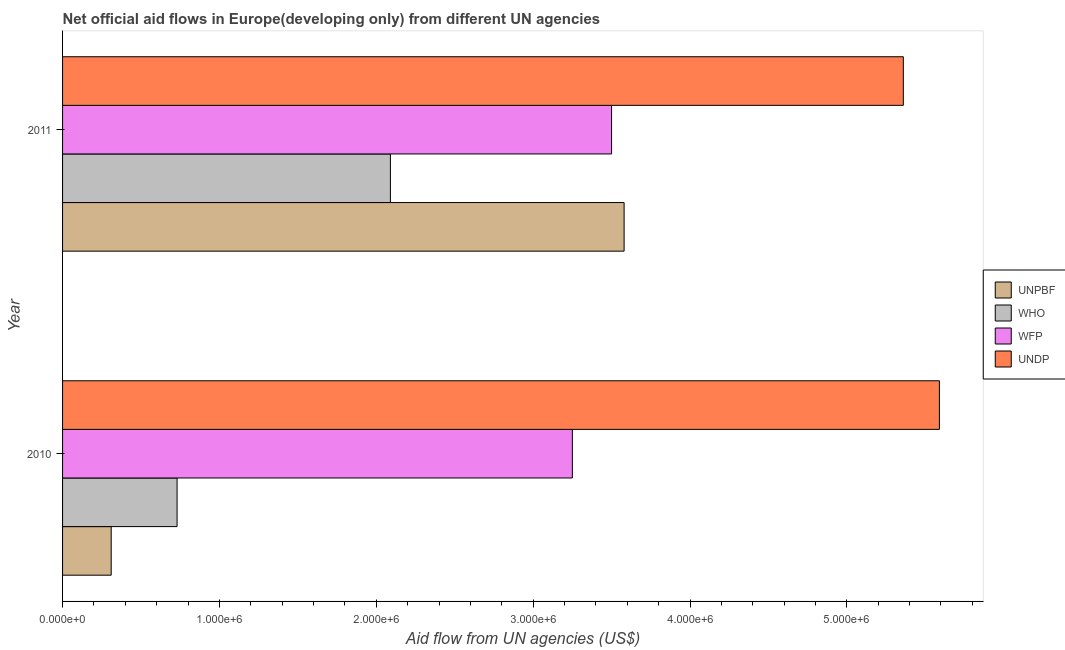How many different coloured bars are there?
Offer a terse response. 4. Are the number of bars per tick equal to the number of legend labels?
Offer a terse response. Yes. Are the number of bars on each tick of the Y-axis equal?
Provide a succinct answer. Yes. How many bars are there on the 2nd tick from the bottom?
Offer a terse response. 4. What is the label of the 1st group of bars from the top?
Ensure brevity in your answer.  2011. In how many cases, is the number of bars for a given year not equal to the number of legend labels?
Provide a short and direct response. 0. What is the amount of aid given by unpbf in 2010?
Your response must be concise. 3.10e+05. Across all years, what is the maximum amount of aid given by undp?
Make the answer very short. 5.59e+06. Across all years, what is the minimum amount of aid given by unpbf?
Offer a very short reply. 3.10e+05. In which year was the amount of aid given by who maximum?
Ensure brevity in your answer.  2011. What is the total amount of aid given by unpbf in the graph?
Provide a short and direct response. 3.89e+06. What is the difference between the amount of aid given by undp in 2010 and that in 2011?
Offer a terse response. 2.30e+05. What is the difference between the amount of aid given by unpbf in 2010 and the amount of aid given by wfp in 2011?
Make the answer very short. -3.19e+06. What is the average amount of aid given by undp per year?
Make the answer very short. 5.48e+06. In the year 2010, what is the difference between the amount of aid given by who and amount of aid given by undp?
Your answer should be compact. -4.86e+06. What is the ratio of the amount of aid given by unpbf in 2010 to that in 2011?
Your answer should be very brief. 0.09. What does the 4th bar from the top in 2011 represents?
Provide a succinct answer. UNPBF. What does the 4th bar from the bottom in 2011 represents?
Give a very brief answer. UNDP. Is it the case that in every year, the sum of the amount of aid given by unpbf and amount of aid given by who is greater than the amount of aid given by wfp?
Your answer should be very brief. No. Are all the bars in the graph horizontal?
Provide a succinct answer. Yes. How many years are there in the graph?
Make the answer very short. 2. Are the values on the major ticks of X-axis written in scientific E-notation?
Your response must be concise. Yes. Does the graph contain grids?
Keep it short and to the point. No. How are the legend labels stacked?
Keep it short and to the point. Vertical. What is the title of the graph?
Ensure brevity in your answer.  Net official aid flows in Europe(developing only) from different UN agencies. Does "UNRWA" appear as one of the legend labels in the graph?
Your response must be concise. No. What is the label or title of the X-axis?
Your response must be concise. Aid flow from UN agencies (US$). What is the label or title of the Y-axis?
Give a very brief answer. Year. What is the Aid flow from UN agencies (US$) in WHO in 2010?
Make the answer very short. 7.30e+05. What is the Aid flow from UN agencies (US$) in WFP in 2010?
Offer a terse response. 3.25e+06. What is the Aid flow from UN agencies (US$) in UNDP in 2010?
Offer a terse response. 5.59e+06. What is the Aid flow from UN agencies (US$) in UNPBF in 2011?
Make the answer very short. 3.58e+06. What is the Aid flow from UN agencies (US$) in WHO in 2011?
Provide a short and direct response. 2.09e+06. What is the Aid flow from UN agencies (US$) in WFP in 2011?
Provide a short and direct response. 3.50e+06. What is the Aid flow from UN agencies (US$) in UNDP in 2011?
Provide a succinct answer. 5.36e+06. Across all years, what is the maximum Aid flow from UN agencies (US$) of UNPBF?
Provide a succinct answer. 3.58e+06. Across all years, what is the maximum Aid flow from UN agencies (US$) in WHO?
Provide a succinct answer. 2.09e+06. Across all years, what is the maximum Aid flow from UN agencies (US$) of WFP?
Keep it short and to the point. 3.50e+06. Across all years, what is the maximum Aid flow from UN agencies (US$) of UNDP?
Provide a short and direct response. 5.59e+06. Across all years, what is the minimum Aid flow from UN agencies (US$) of WHO?
Your answer should be very brief. 7.30e+05. Across all years, what is the minimum Aid flow from UN agencies (US$) of WFP?
Make the answer very short. 3.25e+06. Across all years, what is the minimum Aid flow from UN agencies (US$) in UNDP?
Offer a terse response. 5.36e+06. What is the total Aid flow from UN agencies (US$) of UNPBF in the graph?
Offer a terse response. 3.89e+06. What is the total Aid flow from UN agencies (US$) of WHO in the graph?
Make the answer very short. 2.82e+06. What is the total Aid flow from UN agencies (US$) in WFP in the graph?
Keep it short and to the point. 6.75e+06. What is the total Aid flow from UN agencies (US$) of UNDP in the graph?
Give a very brief answer. 1.10e+07. What is the difference between the Aid flow from UN agencies (US$) in UNPBF in 2010 and that in 2011?
Your answer should be very brief. -3.27e+06. What is the difference between the Aid flow from UN agencies (US$) in WHO in 2010 and that in 2011?
Your answer should be compact. -1.36e+06. What is the difference between the Aid flow from UN agencies (US$) in UNDP in 2010 and that in 2011?
Keep it short and to the point. 2.30e+05. What is the difference between the Aid flow from UN agencies (US$) of UNPBF in 2010 and the Aid flow from UN agencies (US$) of WHO in 2011?
Ensure brevity in your answer.  -1.78e+06. What is the difference between the Aid flow from UN agencies (US$) in UNPBF in 2010 and the Aid flow from UN agencies (US$) in WFP in 2011?
Your answer should be very brief. -3.19e+06. What is the difference between the Aid flow from UN agencies (US$) of UNPBF in 2010 and the Aid flow from UN agencies (US$) of UNDP in 2011?
Offer a terse response. -5.05e+06. What is the difference between the Aid flow from UN agencies (US$) in WHO in 2010 and the Aid flow from UN agencies (US$) in WFP in 2011?
Provide a succinct answer. -2.77e+06. What is the difference between the Aid flow from UN agencies (US$) in WHO in 2010 and the Aid flow from UN agencies (US$) in UNDP in 2011?
Your answer should be compact. -4.63e+06. What is the difference between the Aid flow from UN agencies (US$) of WFP in 2010 and the Aid flow from UN agencies (US$) of UNDP in 2011?
Provide a short and direct response. -2.11e+06. What is the average Aid flow from UN agencies (US$) in UNPBF per year?
Provide a short and direct response. 1.94e+06. What is the average Aid flow from UN agencies (US$) in WHO per year?
Make the answer very short. 1.41e+06. What is the average Aid flow from UN agencies (US$) of WFP per year?
Provide a succinct answer. 3.38e+06. What is the average Aid flow from UN agencies (US$) of UNDP per year?
Keep it short and to the point. 5.48e+06. In the year 2010, what is the difference between the Aid flow from UN agencies (US$) of UNPBF and Aid flow from UN agencies (US$) of WHO?
Your response must be concise. -4.20e+05. In the year 2010, what is the difference between the Aid flow from UN agencies (US$) in UNPBF and Aid flow from UN agencies (US$) in WFP?
Keep it short and to the point. -2.94e+06. In the year 2010, what is the difference between the Aid flow from UN agencies (US$) of UNPBF and Aid flow from UN agencies (US$) of UNDP?
Provide a succinct answer. -5.28e+06. In the year 2010, what is the difference between the Aid flow from UN agencies (US$) in WHO and Aid flow from UN agencies (US$) in WFP?
Your answer should be compact. -2.52e+06. In the year 2010, what is the difference between the Aid flow from UN agencies (US$) of WHO and Aid flow from UN agencies (US$) of UNDP?
Your response must be concise. -4.86e+06. In the year 2010, what is the difference between the Aid flow from UN agencies (US$) in WFP and Aid flow from UN agencies (US$) in UNDP?
Your answer should be very brief. -2.34e+06. In the year 2011, what is the difference between the Aid flow from UN agencies (US$) of UNPBF and Aid flow from UN agencies (US$) of WHO?
Ensure brevity in your answer.  1.49e+06. In the year 2011, what is the difference between the Aid flow from UN agencies (US$) in UNPBF and Aid flow from UN agencies (US$) in WFP?
Ensure brevity in your answer.  8.00e+04. In the year 2011, what is the difference between the Aid flow from UN agencies (US$) in UNPBF and Aid flow from UN agencies (US$) in UNDP?
Make the answer very short. -1.78e+06. In the year 2011, what is the difference between the Aid flow from UN agencies (US$) in WHO and Aid flow from UN agencies (US$) in WFP?
Ensure brevity in your answer.  -1.41e+06. In the year 2011, what is the difference between the Aid flow from UN agencies (US$) of WHO and Aid flow from UN agencies (US$) of UNDP?
Offer a very short reply. -3.27e+06. In the year 2011, what is the difference between the Aid flow from UN agencies (US$) of WFP and Aid flow from UN agencies (US$) of UNDP?
Provide a succinct answer. -1.86e+06. What is the ratio of the Aid flow from UN agencies (US$) of UNPBF in 2010 to that in 2011?
Provide a short and direct response. 0.09. What is the ratio of the Aid flow from UN agencies (US$) of WHO in 2010 to that in 2011?
Your answer should be very brief. 0.35. What is the ratio of the Aid flow from UN agencies (US$) in WFP in 2010 to that in 2011?
Make the answer very short. 0.93. What is the ratio of the Aid flow from UN agencies (US$) in UNDP in 2010 to that in 2011?
Your response must be concise. 1.04. What is the difference between the highest and the second highest Aid flow from UN agencies (US$) of UNPBF?
Make the answer very short. 3.27e+06. What is the difference between the highest and the second highest Aid flow from UN agencies (US$) in WHO?
Your response must be concise. 1.36e+06. What is the difference between the highest and the second highest Aid flow from UN agencies (US$) in WFP?
Keep it short and to the point. 2.50e+05. What is the difference between the highest and the second highest Aid flow from UN agencies (US$) in UNDP?
Make the answer very short. 2.30e+05. What is the difference between the highest and the lowest Aid flow from UN agencies (US$) of UNPBF?
Keep it short and to the point. 3.27e+06. What is the difference between the highest and the lowest Aid flow from UN agencies (US$) of WHO?
Your response must be concise. 1.36e+06. What is the difference between the highest and the lowest Aid flow from UN agencies (US$) of UNDP?
Your response must be concise. 2.30e+05. 